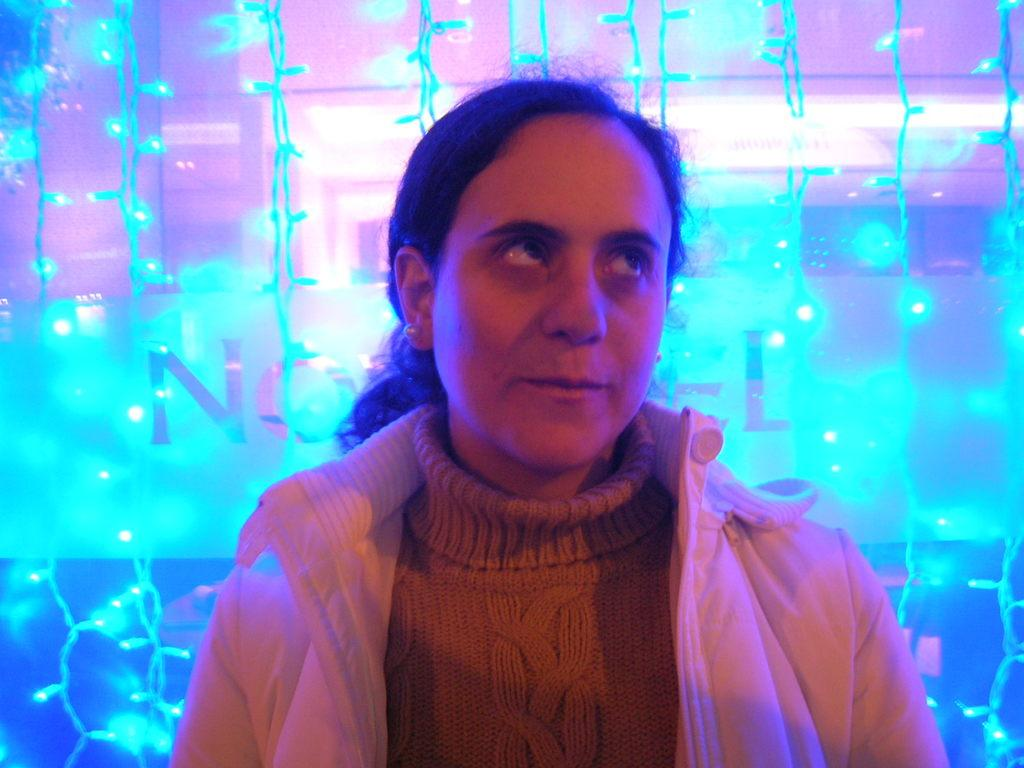Who is present in the image? There is a woman in the image. What is the woman doing in the image? The woman is looking to the right side. What can be seen in the background of the image? There are blue lights in the background of the image. What type of throat lozenges does the woman have in her hand in the image? There is no indication in the image that the woman has any throat lozenges or any object in her hand. 